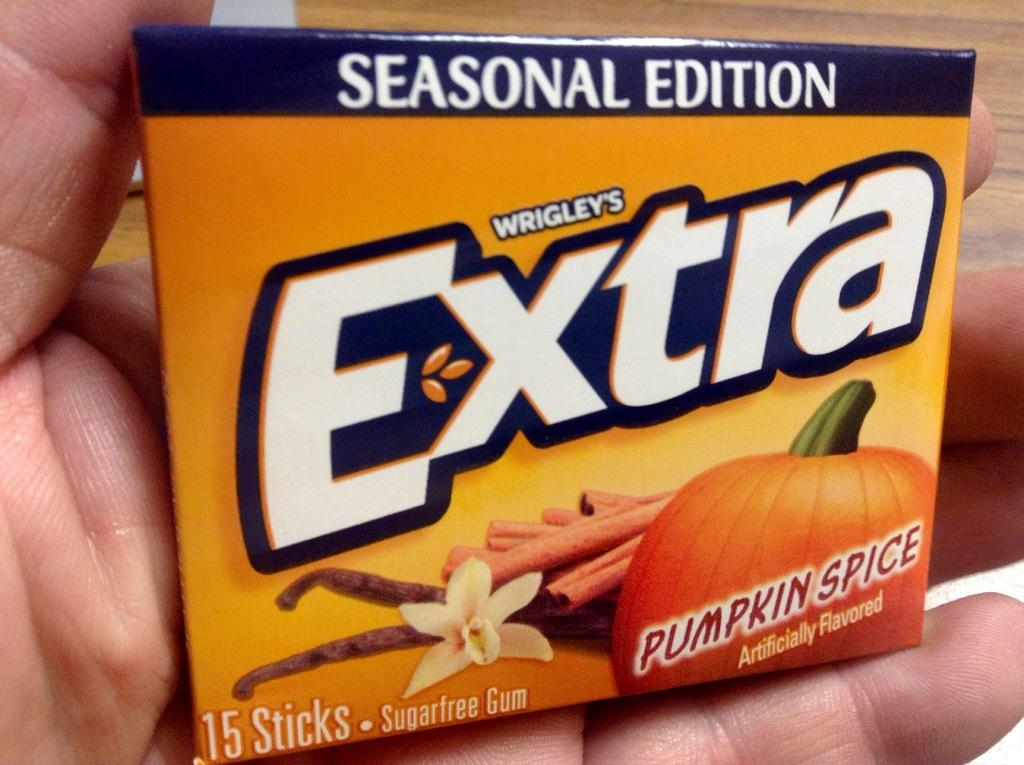<image>
Write a terse but informative summary of the picture. a hand is holding a box of Extra brand gum 